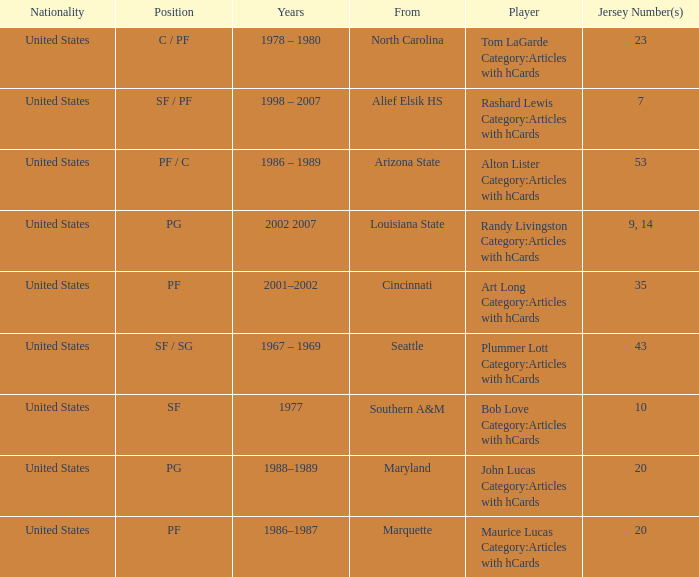Alton Lister Category:Articles with hCards has what as the listed years? 1986 – 1989. 